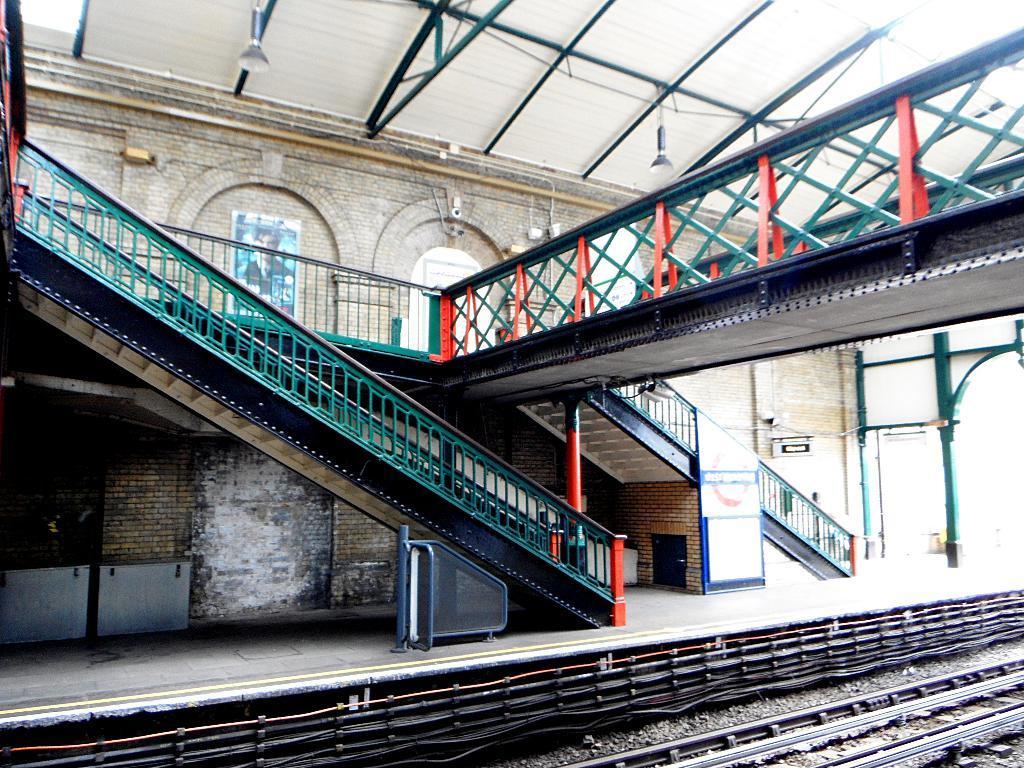Please provide a concise description of this image. This picture is clicked in the railway station. In this picture, we see staircase and a bridge. Behind that, we see a wall on which poster is pasted. At the top of the picture, we see lights. At the bottom of the picture, we see the railway tracks. 